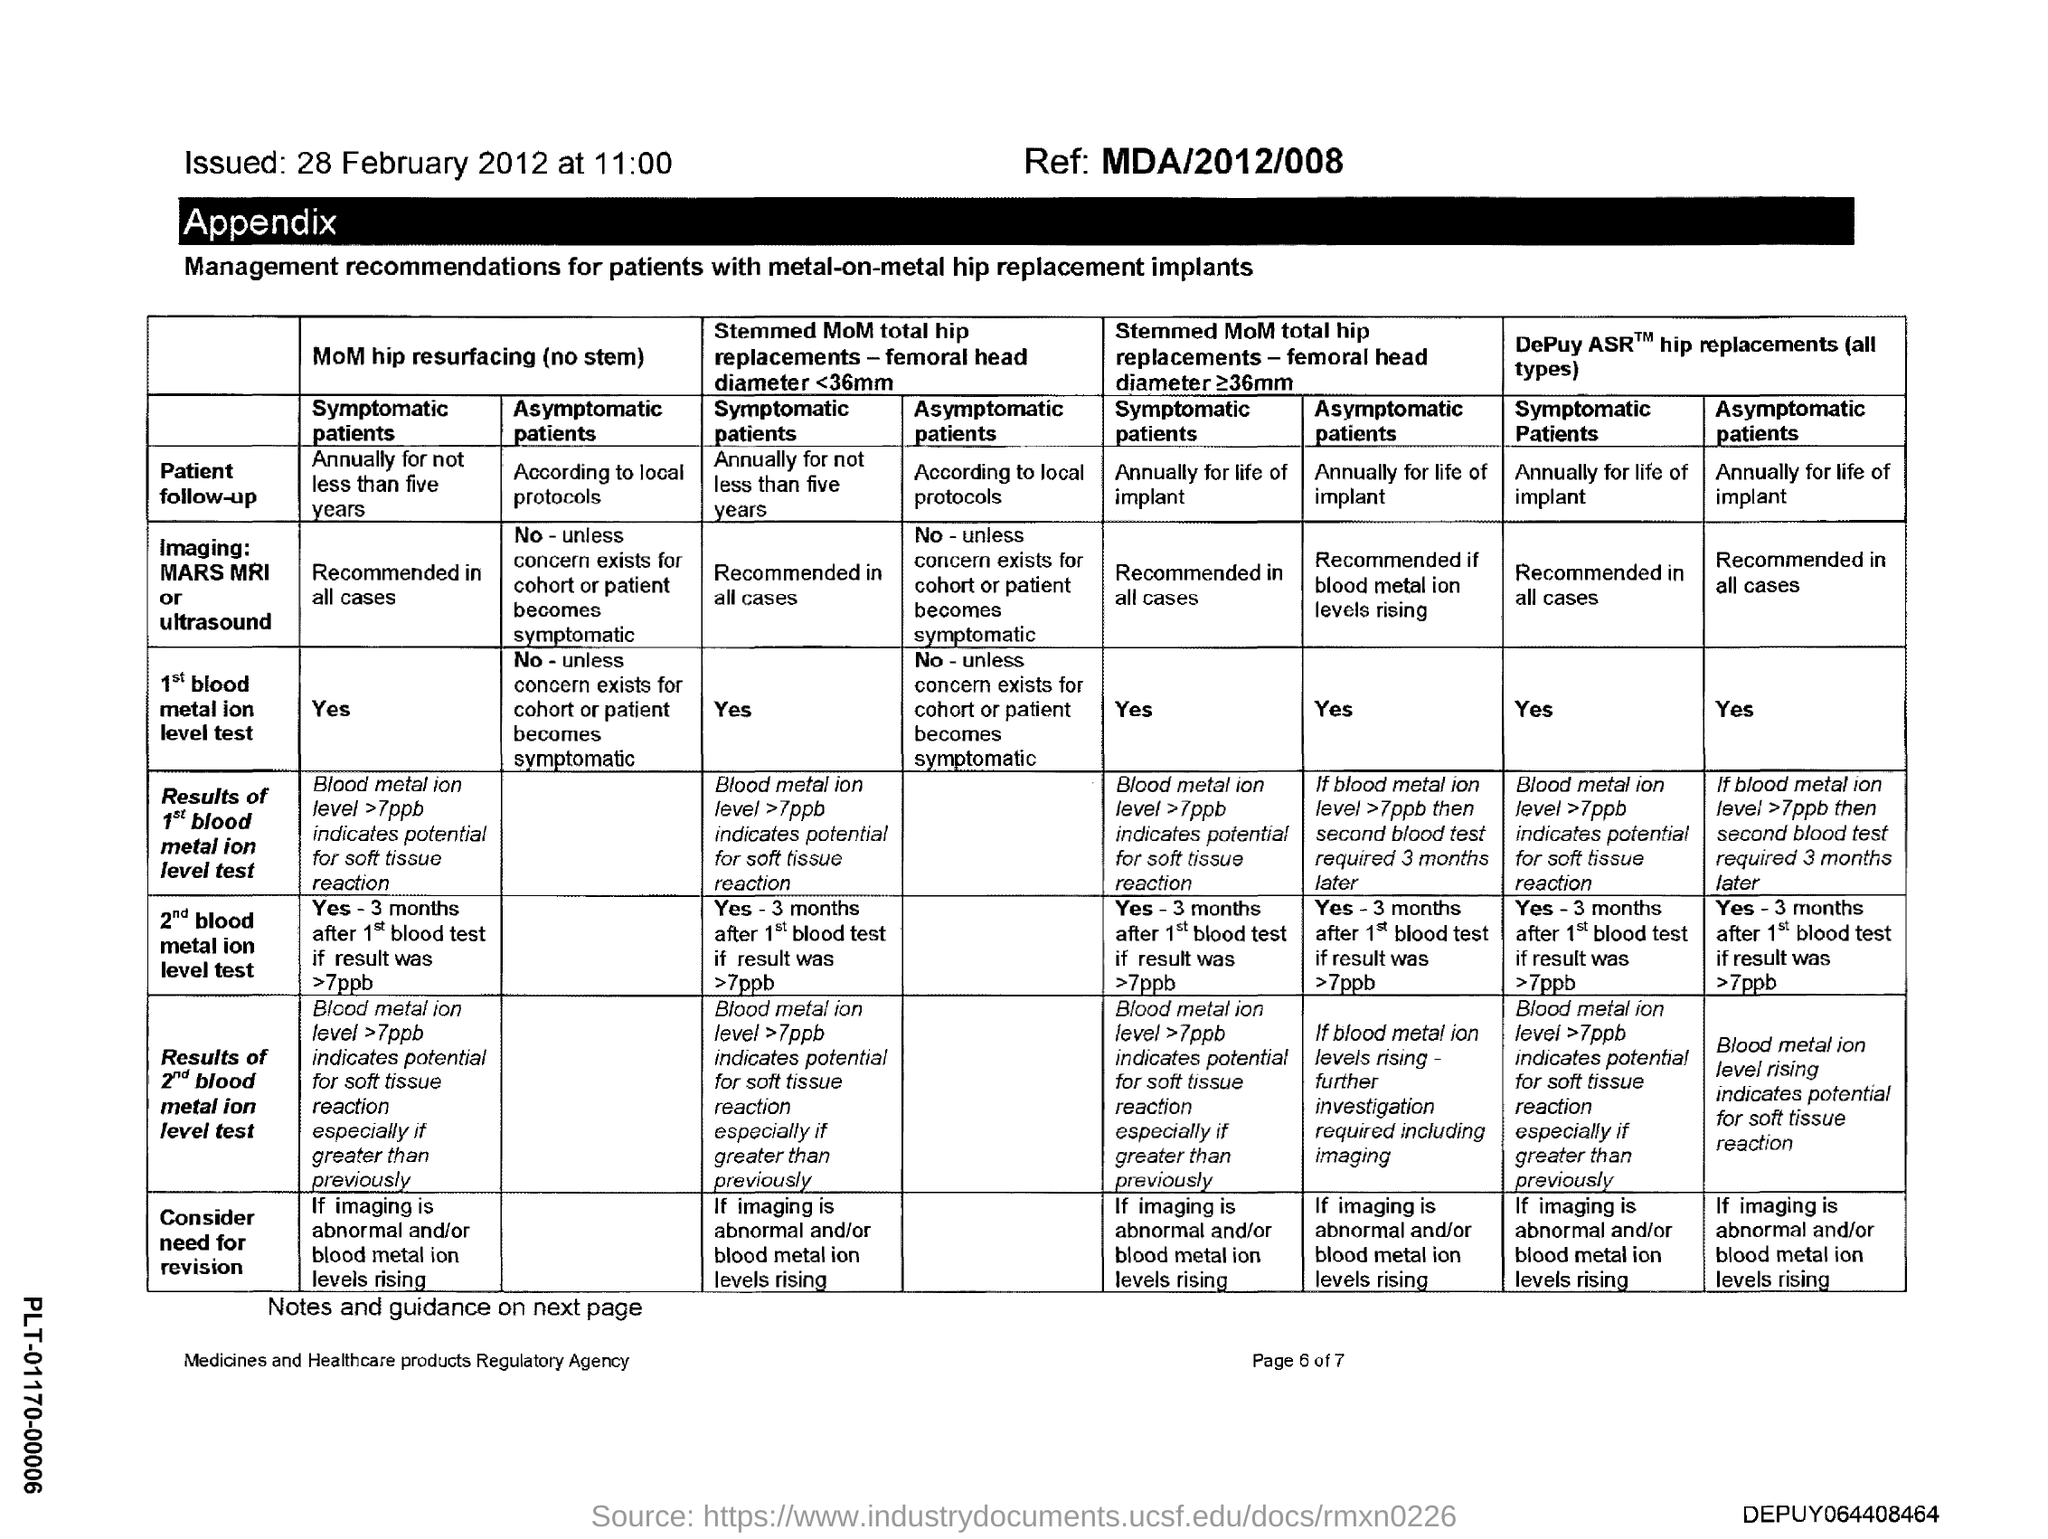Identify some key points in this picture. The ref number is MDA/2012/008. The issued date is February 28, 2012. 